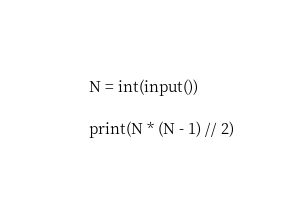Convert code to text. <code><loc_0><loc_0><loc_500><loc_500><_Python_>N = int(input())

print(N * (N - 1) // 2)</code> 